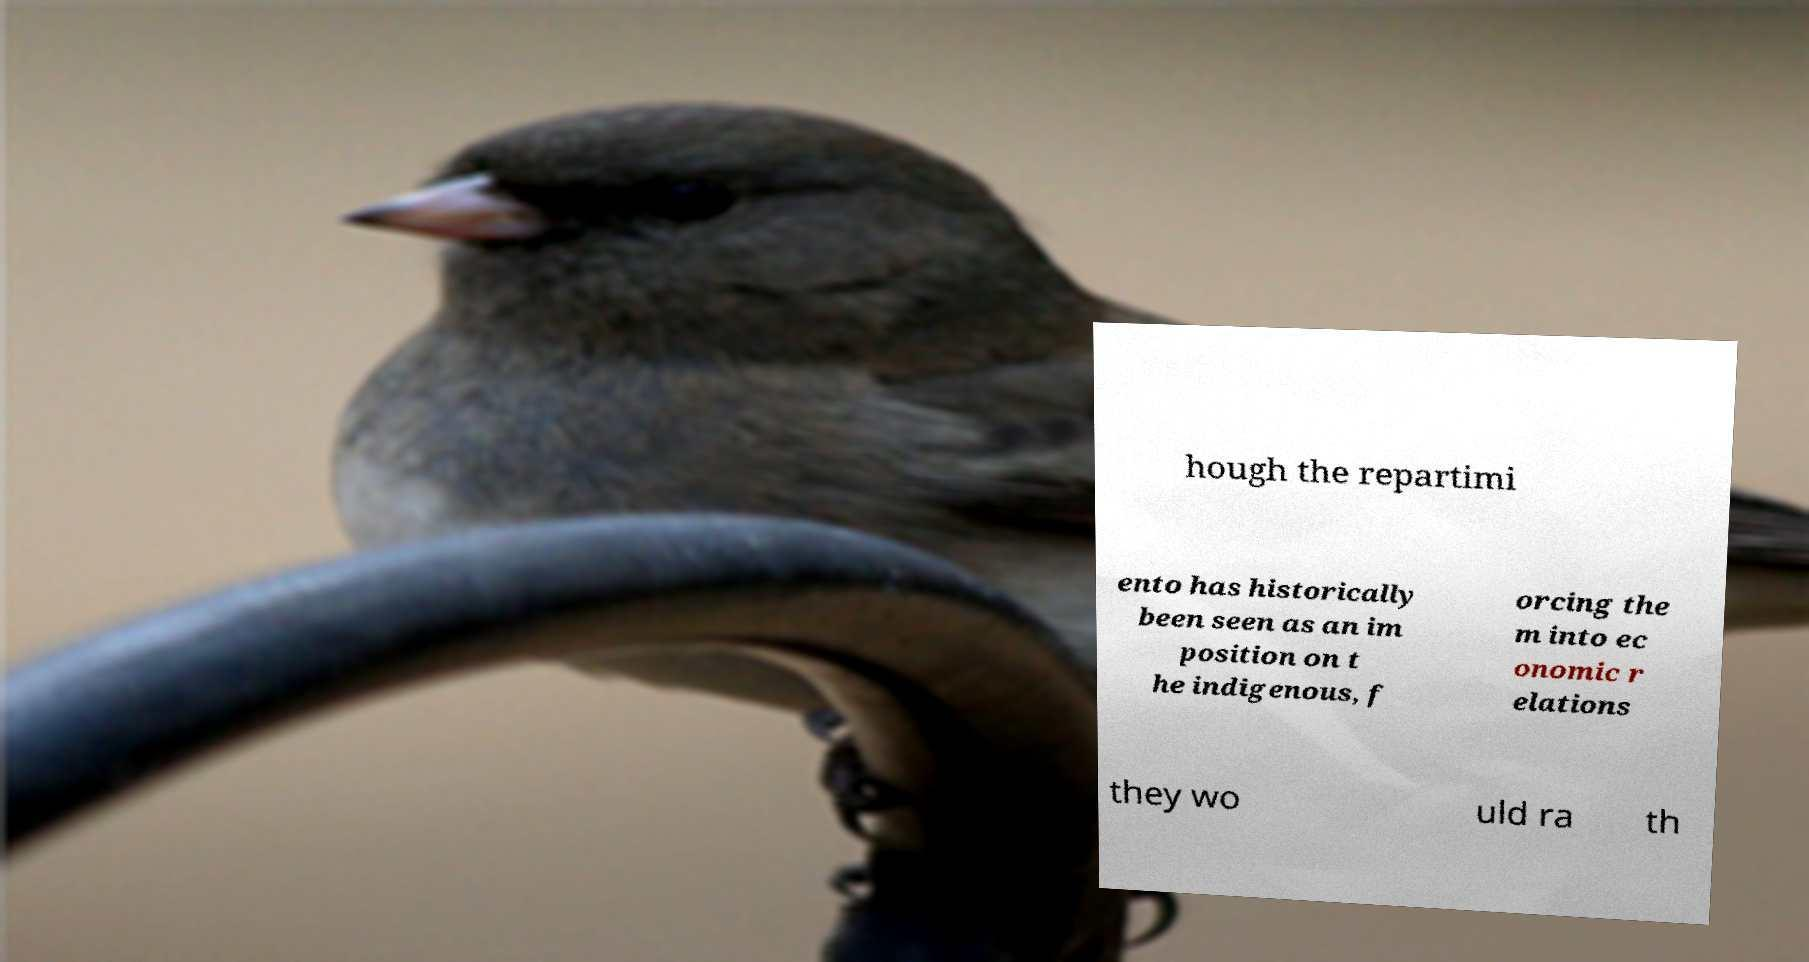Can you accurately transcribe the text from the provided image for me? hough the repartimi ento has historically been seen as an im position on t he indigenous, f orcing the m into ec onomic r elations they wo uld ra th 